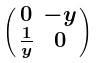<formula> <loc_0><loc_0><loc_500><loc_500>\begin{psmallmatrix} 0 & - y \\ \frac { 1 } { y } & 0 \end{psmallmatrix}</formula> 